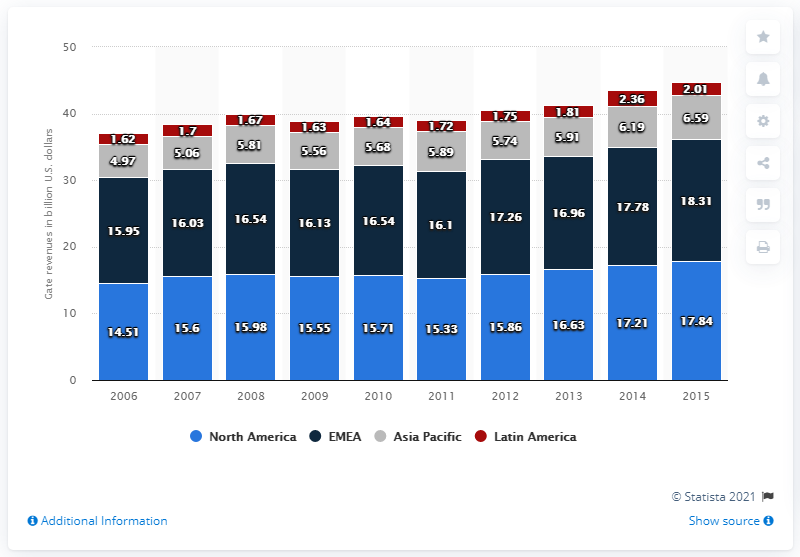Mention a couple of crucial points in this snapshot. In 2010, the amount of revenue generated from gate receipts in North America was 15.86. 